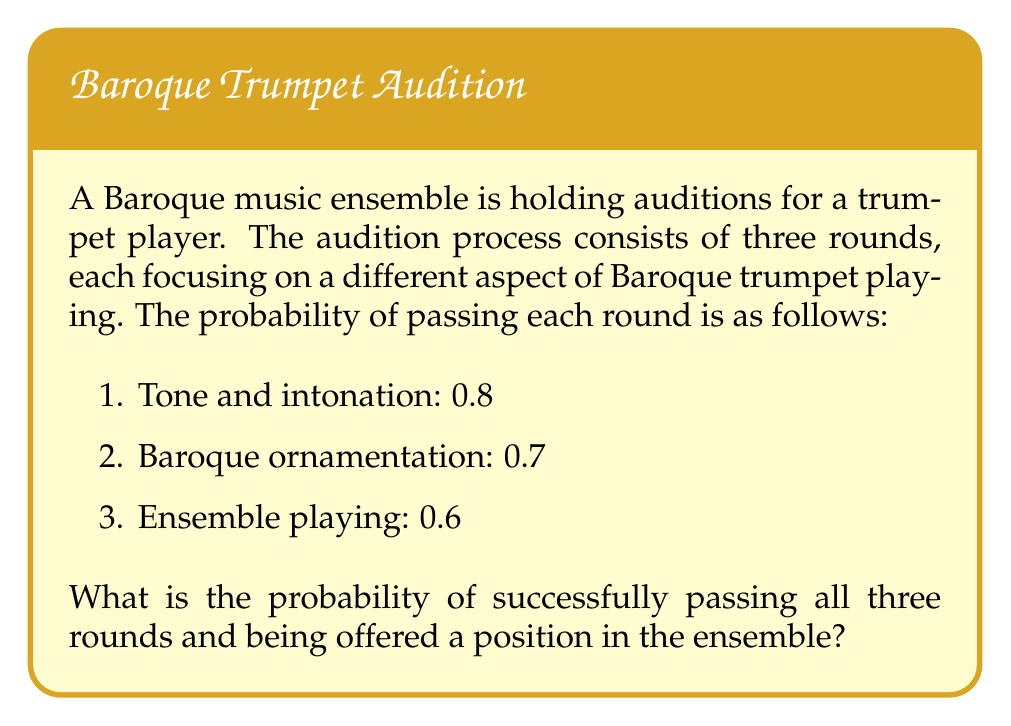Could you help me with this problem? To solve this problem, we need to calculate the probability of succeeding in all three rounds. Since all rounds must be passed, we use the multiplication rule of probability for independent events.

Let's define the events:
$A$: Passing the tone and intonation round
$B$: Passing the Baroque ornamentation round
$C$: Passing the ensemble playing round

Given probabilities:
$P(A) = 0.8$
$P(B) = 0.7$
$P(C) = 0.6$

The probability of passing all three rounds is:

$$P(\text{Success}) = P(A \cap B \cap C) = P(A) \times P(B) \times P(C)$$

Substituting the values:

$$P(\text{Success}) = 0.8 \times 0.7 \times 0.6$$

Calculating:

$$P(\text{Success}) = 0.336$$

Therefore, the probability of successfully passing all three rounds and being offered a position in the ensemble is 0.336 or 33.6%.
Answer: 0.336 